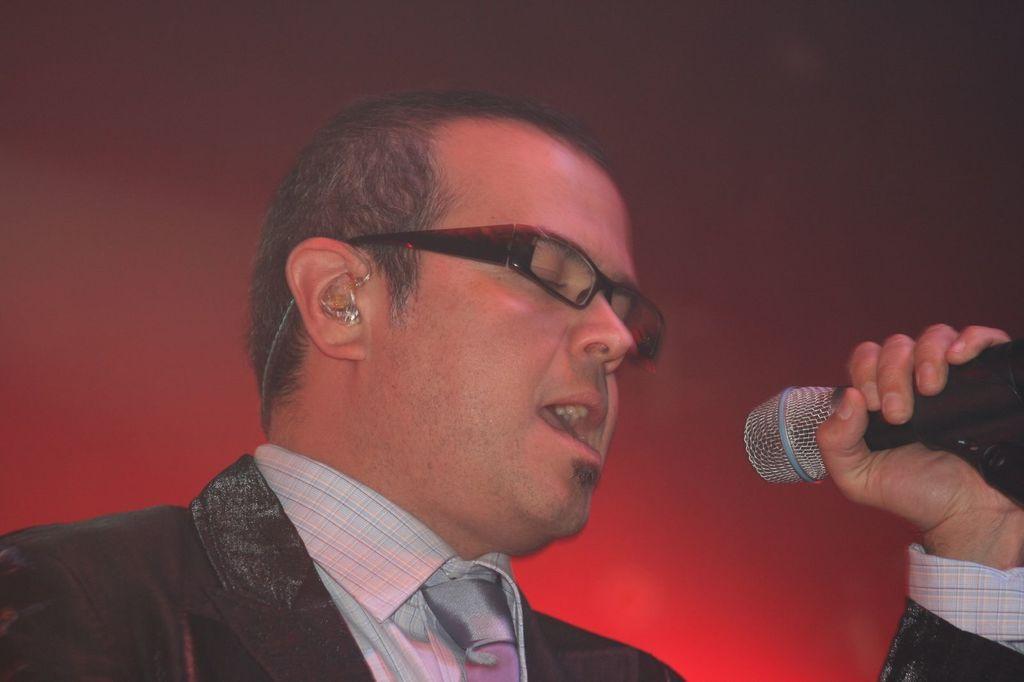Could you give a brief overview of what you see in this image? In the center we can see one man standing and holding microphone. And he is singing. 